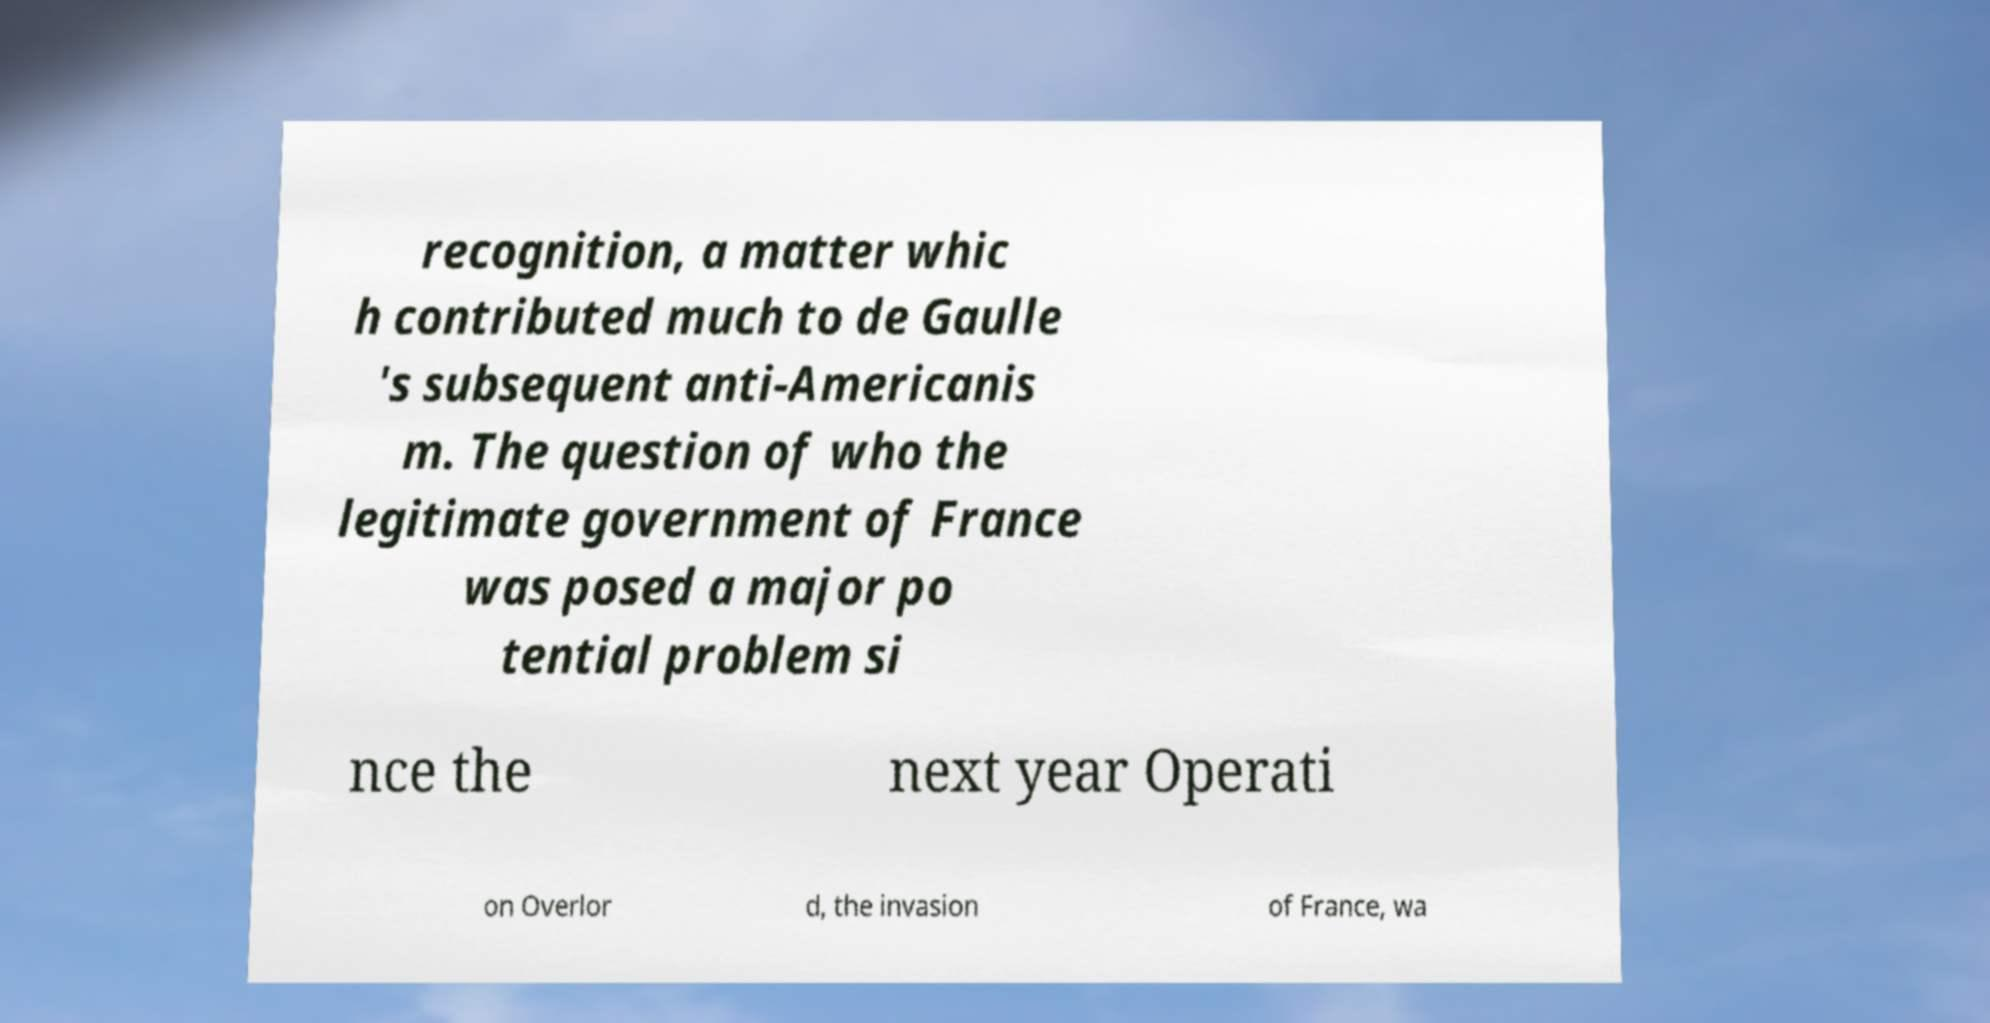What messages or text are displayed in this image? I need them in a readable, typed format. recognition, a matter whic h contributed much to de Gaulle 's subsequent anti-Americanis m. The question of who the legitimate government of France was posed a major po tential problem si nce the next year Operati on Overlor d, the invasion of France, wa 